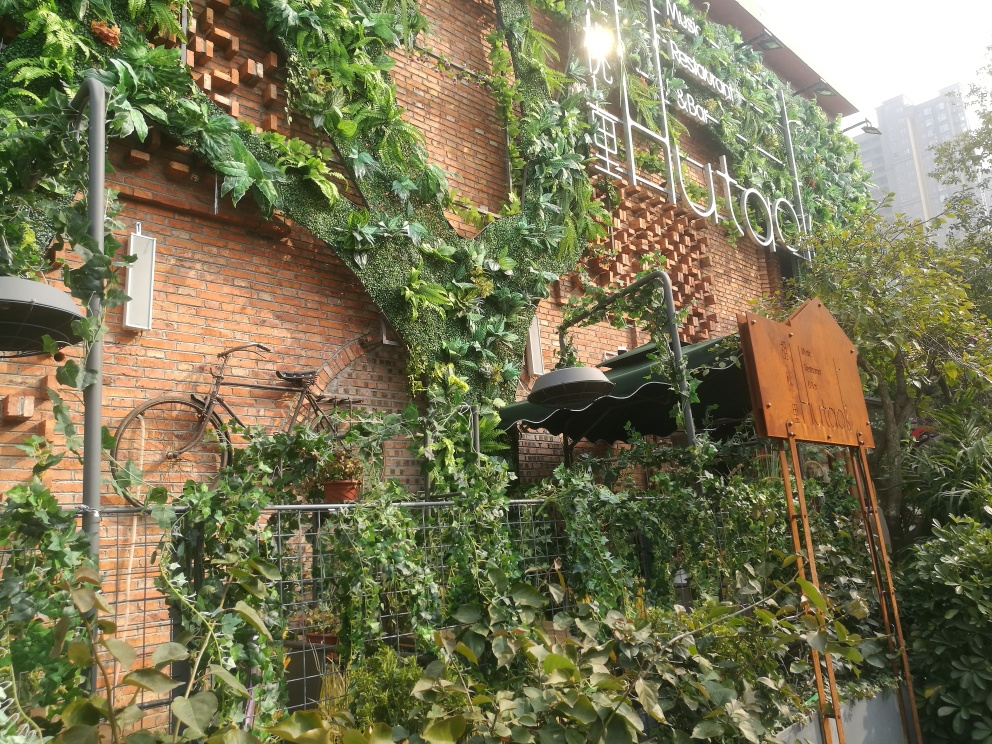What kind of establishment is this, indicated by the sign? The sign on the wall suggests that this is a restaurant, as it includes the word 'Restaurant' prominently displayed in a stylized, vertical format, adding to the establishment's aesthetic appeal. Could you describe the style of the restaurant's sign and its surroundings? The restaurant sign features modern, clean lines with a green, plant-like design that complements the surrounding overgrown ivy. The signage's vertical orientation and the utilization of white space create an attractive contrast against the textured brick wall. 